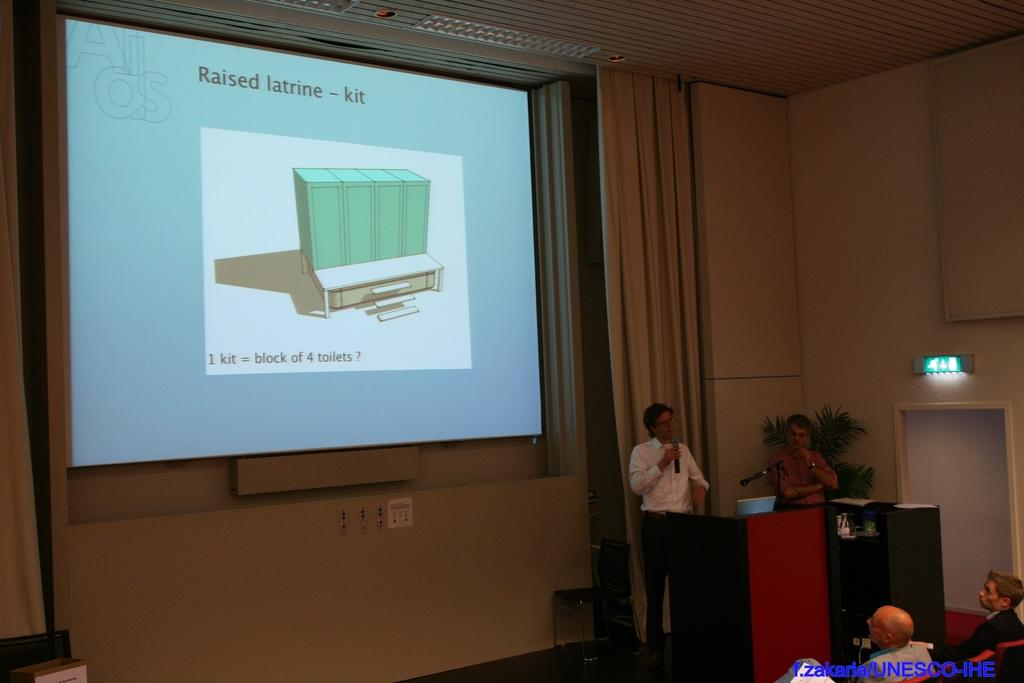<image>
Provide a brief description of the given image. a speaker in front of an audience about a raised latrine kit. 